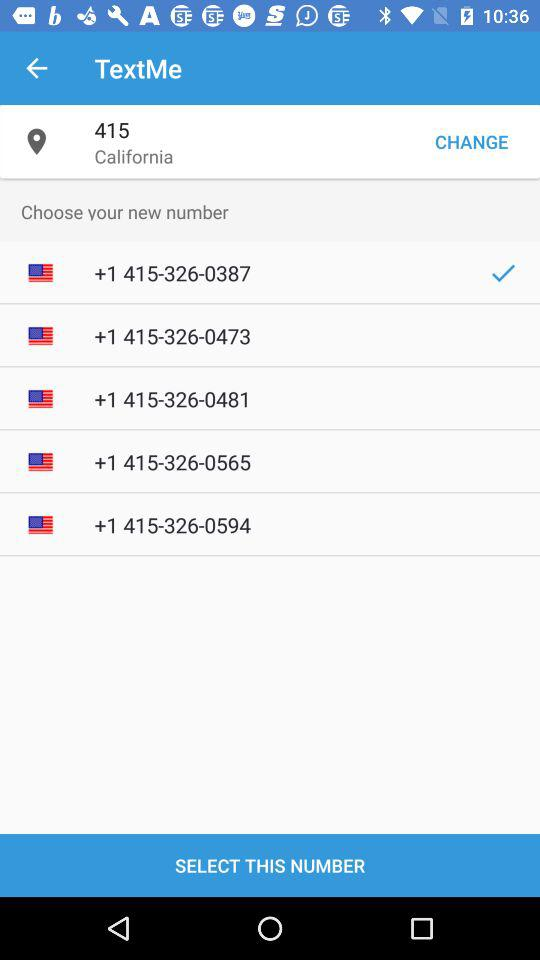How many numbers are available for selection?
Answer the question using a single word or phrase. 5 